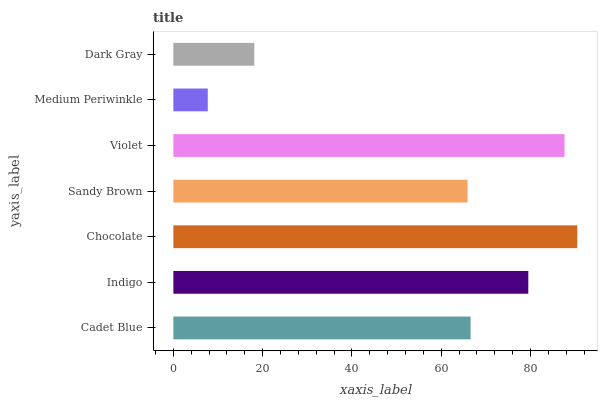Is Medium Periwinkle the minimum?
Answer yes or no. Yes. Is Chocolate the maximum?
Answer yes or no. Yes. Is Indigo the minimum?
Answer yes or no. No. Is Indigo the maximum?
Answer yes or no. No. Is Indigo greater than Cadet Blue?
Answer yes or no. Yes. Is Cadet Blue less than Indigo?
Answer yes or no. Yes. Is Cadet Blue greater than Indigo?
Answer yes or no. No. Is Indigo less than Cadet Blue?
Answer yes or no. No. Is Cadet Blue the high median?
Answer yes or no. Yes. Is Cadet Blue the low median?
Answer yes or no. Yes. Is Violet the high median?
Answer yes or no. No. Is Sandy Brown the low median?
Answer yes or no. No. 